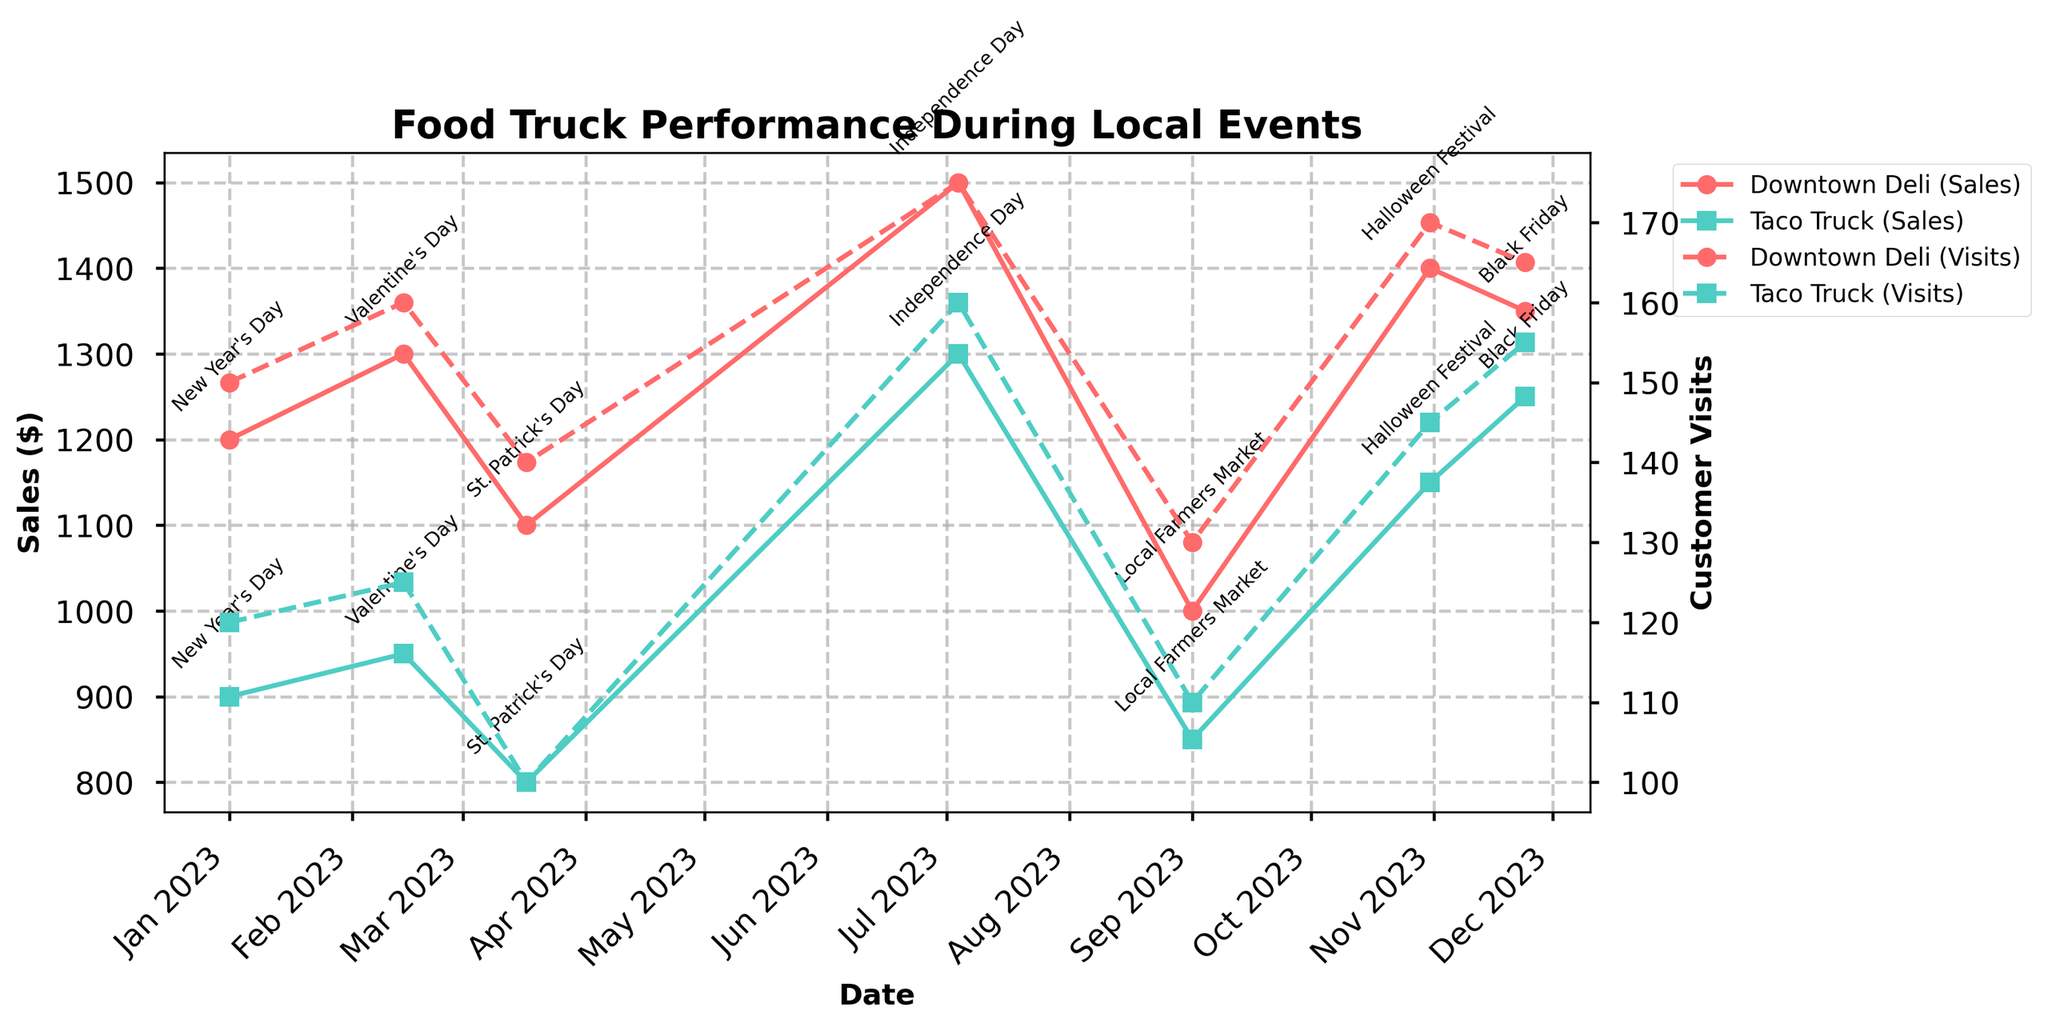What's the title of the figure? The title of the figure is usually located at the top of the plot. Here, it's in a bold font and specifies what the graph is about.
Answer: Food Truck Performance During Local Events What are the two food trucks shown in the plot? The names of the food trucks are indicated by the labels in the legend.
Answer: Downtown Deli, Taco Truck How are Sales and Customer Visits distinguished in the plot? Sales are shown with solid lines and Customer Visits with dashed lines, with each food truck having its own color.
Answer: Sales with solid lines, Customer Visits with dashed lines Is there a time when the Taco Truck made more sales than Downtown Deli? Compare the sales lines for both trucks across different dates. Taco Truck has higher sales than Downtown Deli on July 4th.
Answer: July 4th On which event did Downtown Deli have the highest Customer Visits? Check the peak value of the dashed line for Downtown Deli. The highest point is on July 4th.
Answer: Independence Day What is the trend of Customer Visits for Downtown Deli from July 4th to Black Friday? Observe the dashed line for Downtown Deli between these dates. There is a fluctuation, but the overall trend is stable with minor differences.
Answer: Fluctuating but generally stable What is the difference in Sales between Downtown Deli and Taco Truck on Halloween? Compare the sales values (solid lines) for both trucks on October 31st, then subtract the values. Downtown Deli has 1400 and Taco Truck has 1150.
Answer: 250 Which event saw the lowest Customer Visits for both food trucks? Compare the lowest points on the dashed lines for both trucks. The lowest Customer Visits are on the Local Farmers Market day.
Answer: Local Farmers Market How does Downtown Deli's Sales on Valentine's Day compare to New Year's Day? Check the sales values on February 14th and January 1st for Downtown Deli. Sales on Valentine's Day are slightly higher (1300) than New Year's Day (1200).
Answer: Higher on Valentine’s Day by 100 What is the average Sales for Taco Truck across all events? Add up all the sales values for Taco Truck and divide by the number of events (6): (900 + 950 + 800 + 1300 + 850 + 1150 + 1250) / 7 = 9000 / 7.
Answer: 1285 